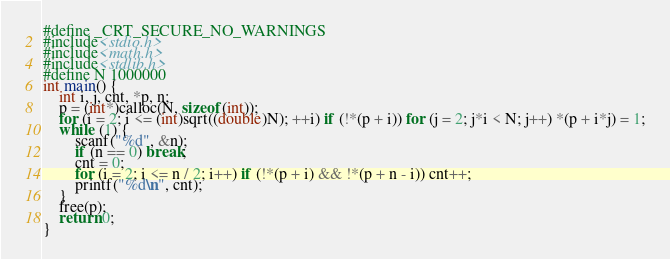<code> <loc_0><loc_0><loc_500><loc_500><_C_>#define _CRT_SECURE_NO_WARNINGS
#include<stdio.h>
#include<math.h>
#include<stdlib.h>
#define N 1000000
int main() {
	int i, j, cnt, *p, n;
	p = (int*)calloc(N, sizeof(int));
	for (i = 2; i <= (int)sqrt((double)N); ++i) if (!*(p + i)) for (j = 2; j*i < N; j++) *(p + i*j) = 1;
	while (1) {
		scanf("%d", &n);
		if (n == 0) break;
		cnt = 0;
		for (i = 2; i <= n / 2; i++) if (!*(p + i) && !*(p + n - i)) cnt++;
		printf("%d\n", cnt);
	}
	free(p);
	return 0;
}</code> 